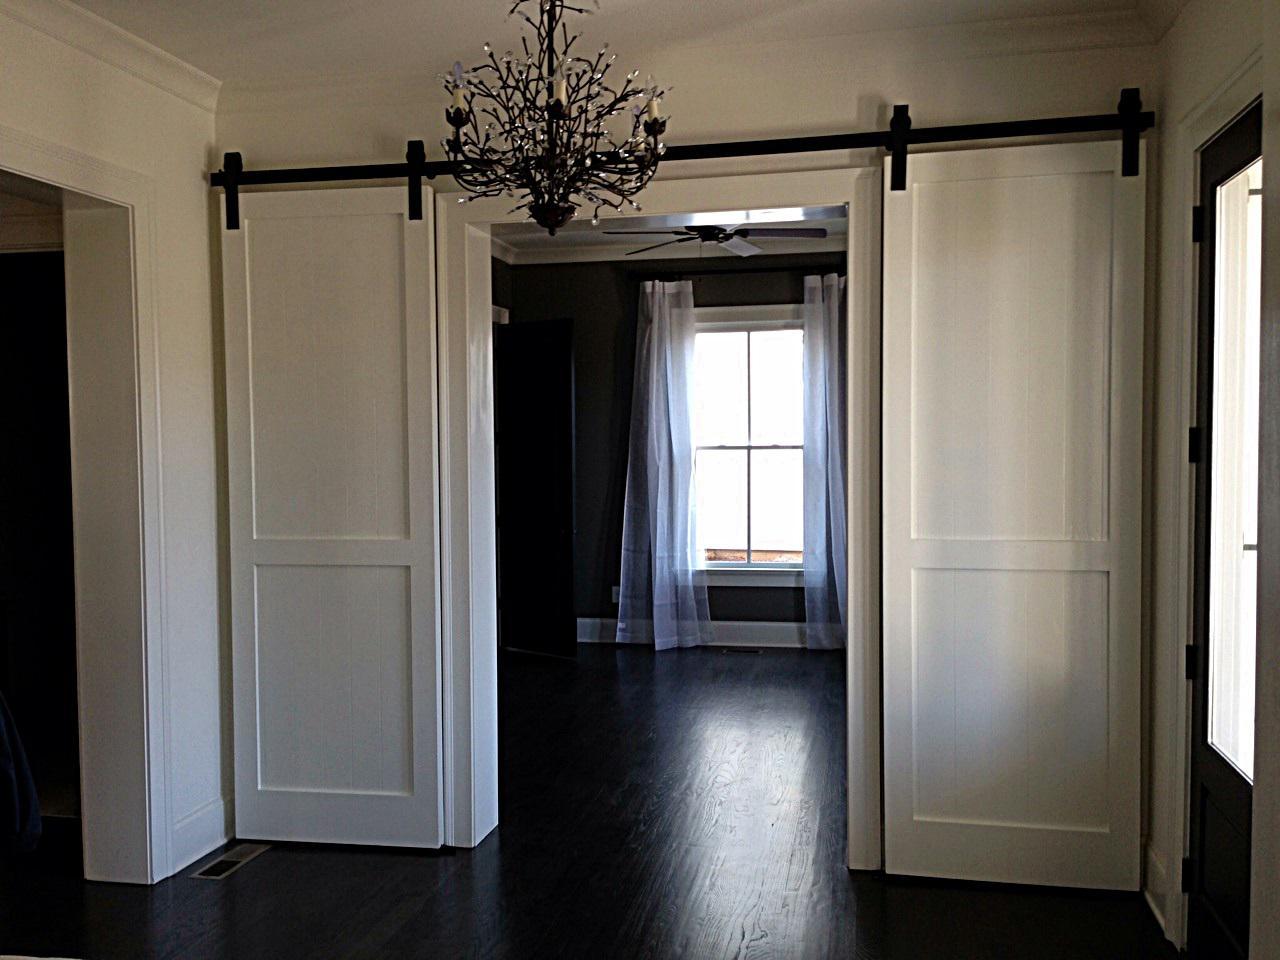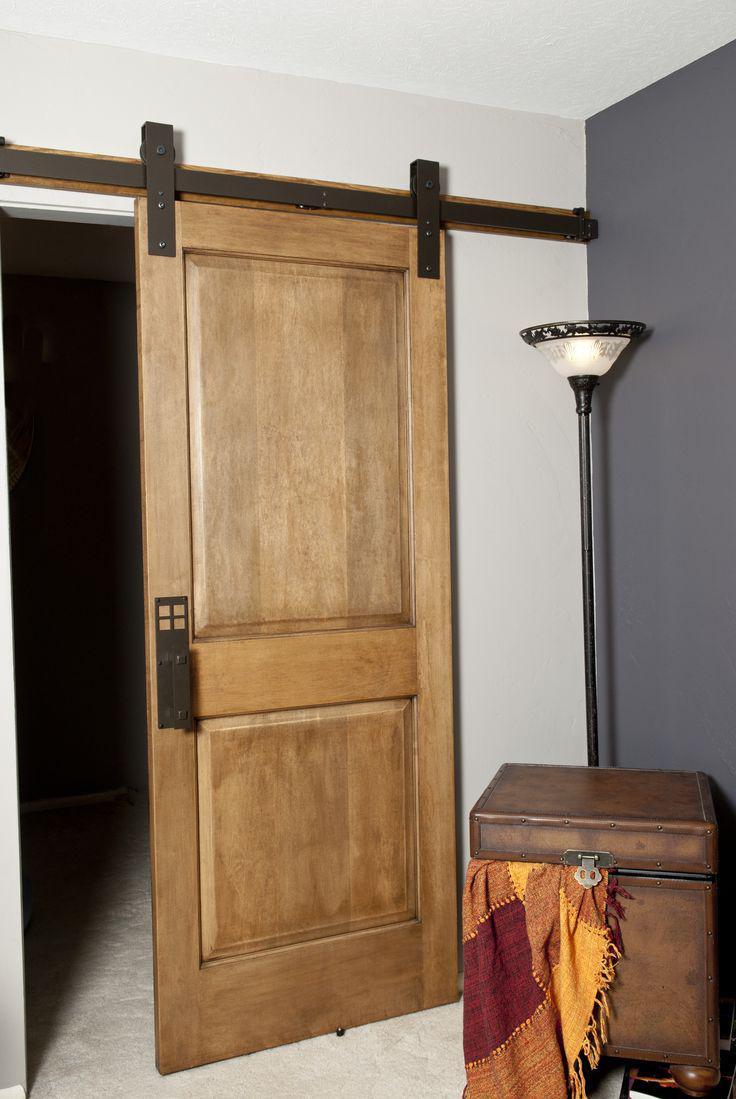The first image is the image on the left, the second image is the image on the right. For the images displayed, is the sentence "There are three sliding doors." factually correct? Answer yes or no. Yes. 